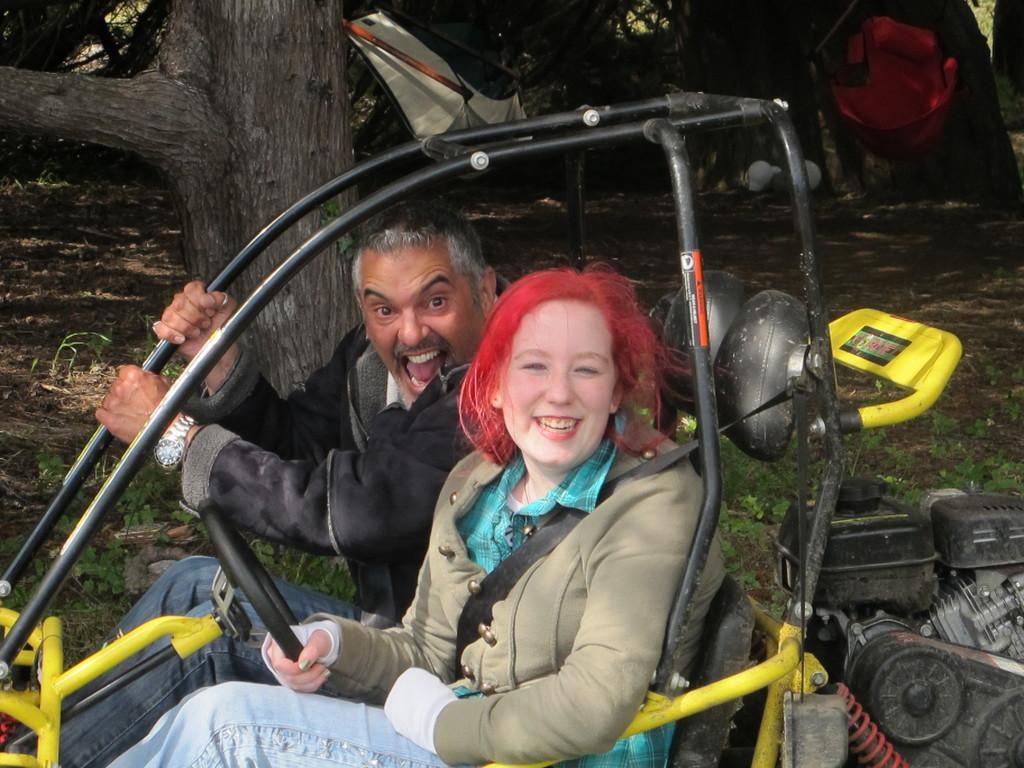Please provide a concise description of this image. In this picture I can see a man and a woman sitting in a vehicle, and in the background there are trees and some other objects. 